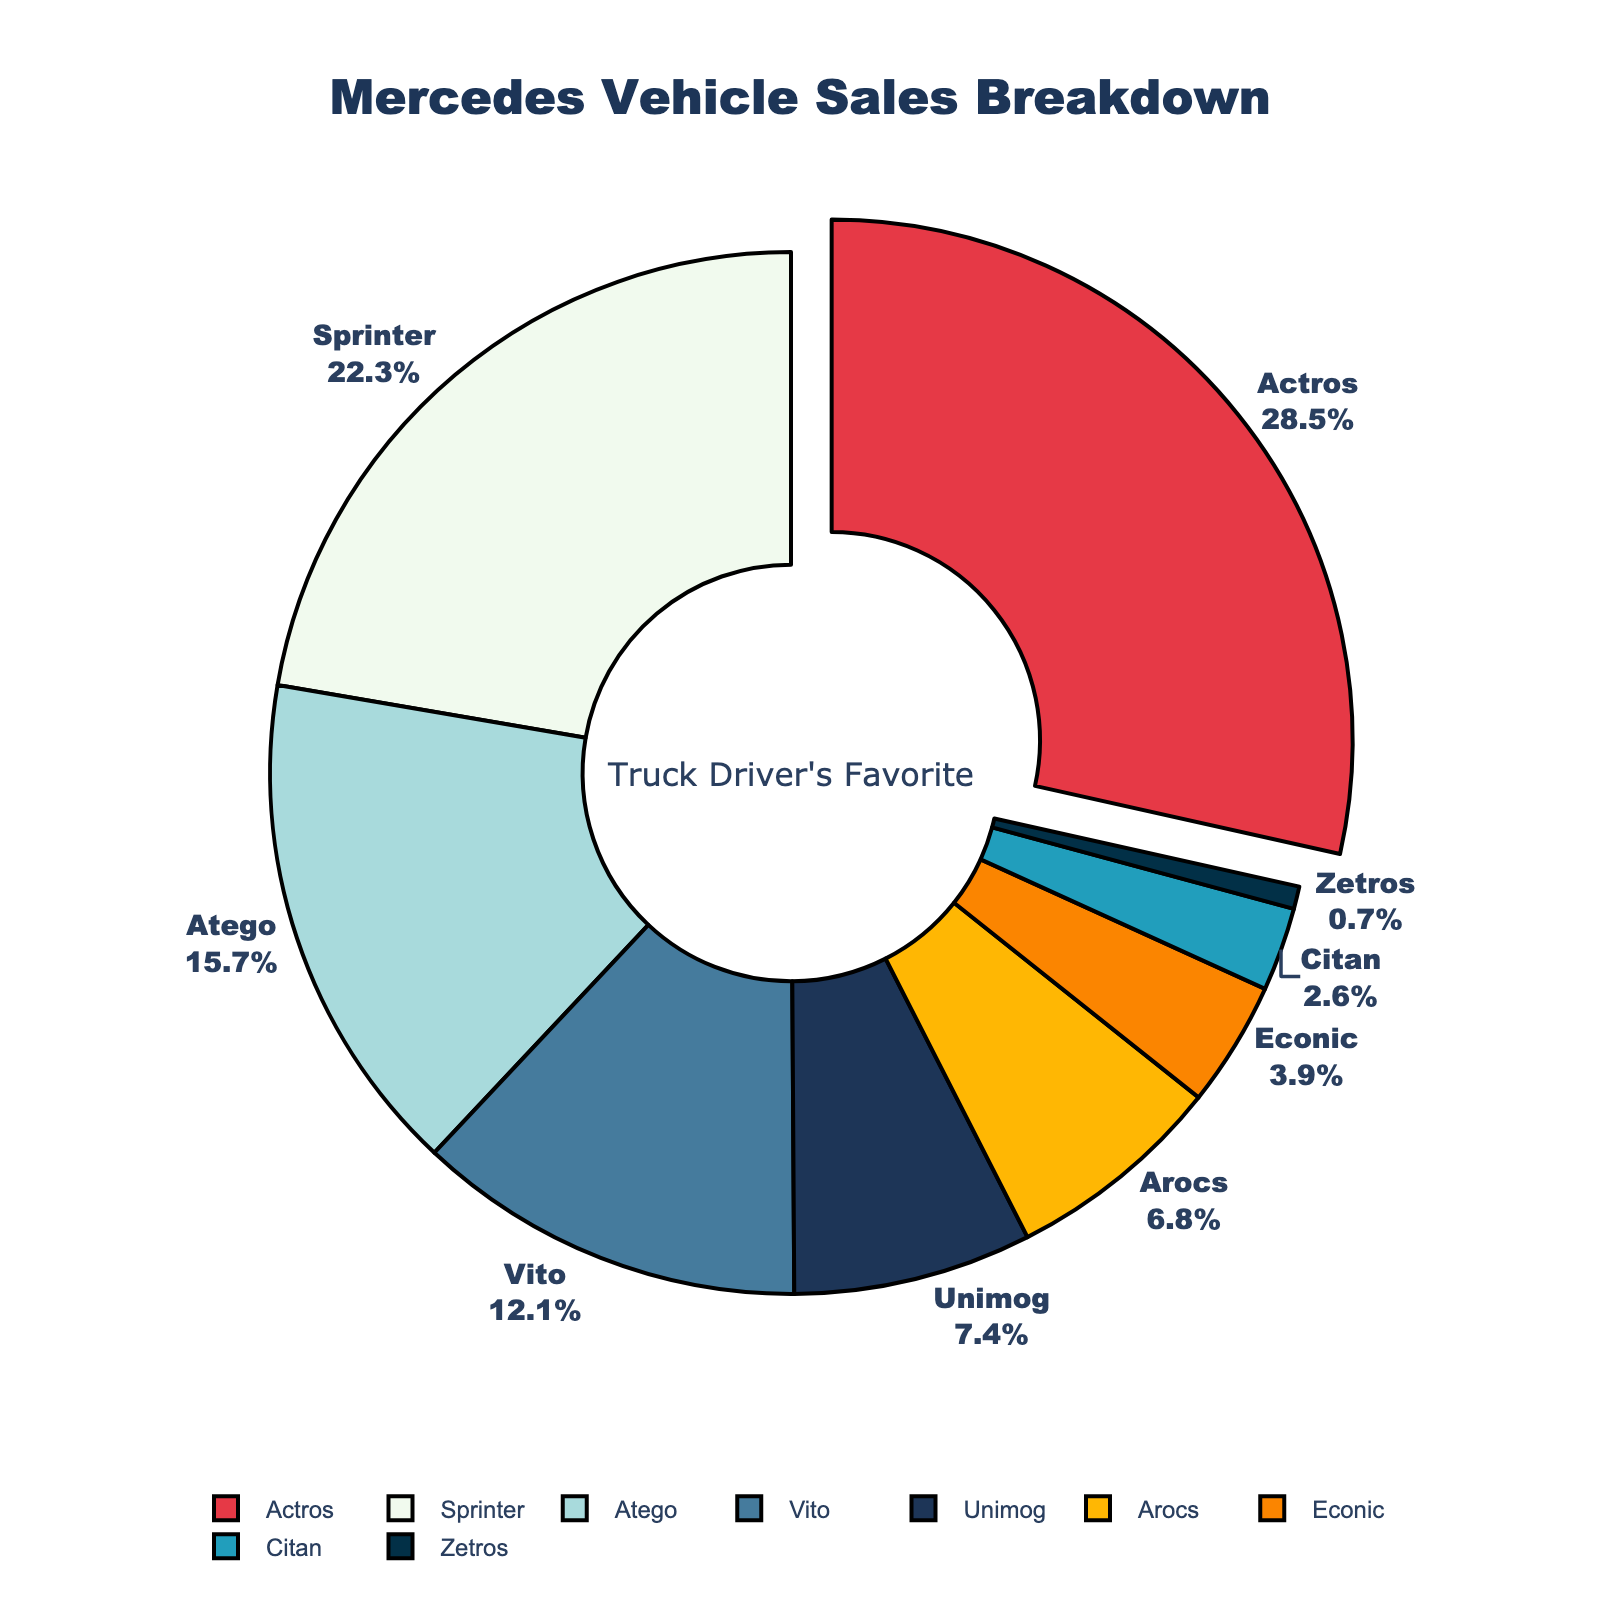How much more is the sales percentage of the Actros compared to the Atego? Actros has a sales percentage of 28.5%, and Atego has a sales percentage of 15.7%. The difference is 28.5 - 15.7 = 12.8%
Answer: 12.8% Which Mercedes model has the highest sales percentage? The largest section in the pie chart, which is also pulled out a bit, represents the Actros with 28.5% of sales.
Answer: Actros Sum the sales percentages of the Sprinter and Vito models. The Sprinter has a sales percentage of 22.3% and the Vito has 12.1%. Adding them together gives 22.3% + 12.1% = 34.4%.
Answer: 34.4% Which vehicle model has the smallest sales percentage and what is that percentage? The smallest section in the pie chart belongs to the Zetros, which has a sales percentage of 0.7%.
Answer: Zetros, 0.7% What is the combined sales percentage of the models that make up less than 10% each? The models with less than 10% sales each are Unimog (7.4%), Arocs (6.8%), Econic (3.9%), Citan (2.6%), and Zetros (0.7%). Sum them up: 7.4% + 6.8% + 3.9% + 2.6% + 0.7% = 21.4%.
Answer: 21.4% Which two models have a combined sales percentage closest to 30%? Comparing various combinations, Sprinter (22.3%) + Econic (3.9%) = 26.2%, Actros (28.5%) + Zetros (0.7%) = 29.2%, etc. The closest combination to 30% is Sprinter (22.3%) + Citan (2.6%) + Unimog (7.4%) = 32.3%.
Answer: Actros and Atego Which model has greater sales, Vito or Atego? Referring to the pie chart, the sales percentage of Atego (15.7%) is higher than that of Vito (12.1%).
Answer: Atego What is the average sales percentage of the top three models? The top three models are Actros (28.5%), Sprinter (22.3%), and Atego (15.7%). The average is (28.5 + 22.3 + 15.7) / 3 = 22.17%.
Answer: 22.17% Count the number of models that have a sales percentage greater than 10%. Actros (28.5%), Sprinter (22.3%), Atego (15.7%), and Vito (12.1%) each have a sales percentage greater than 10%. There are 4 such models.
Answer: 4 What color represents the Econic model in the pie chart? The Econic model's section in the pie chart is colored in orange.
Answer: Orange 